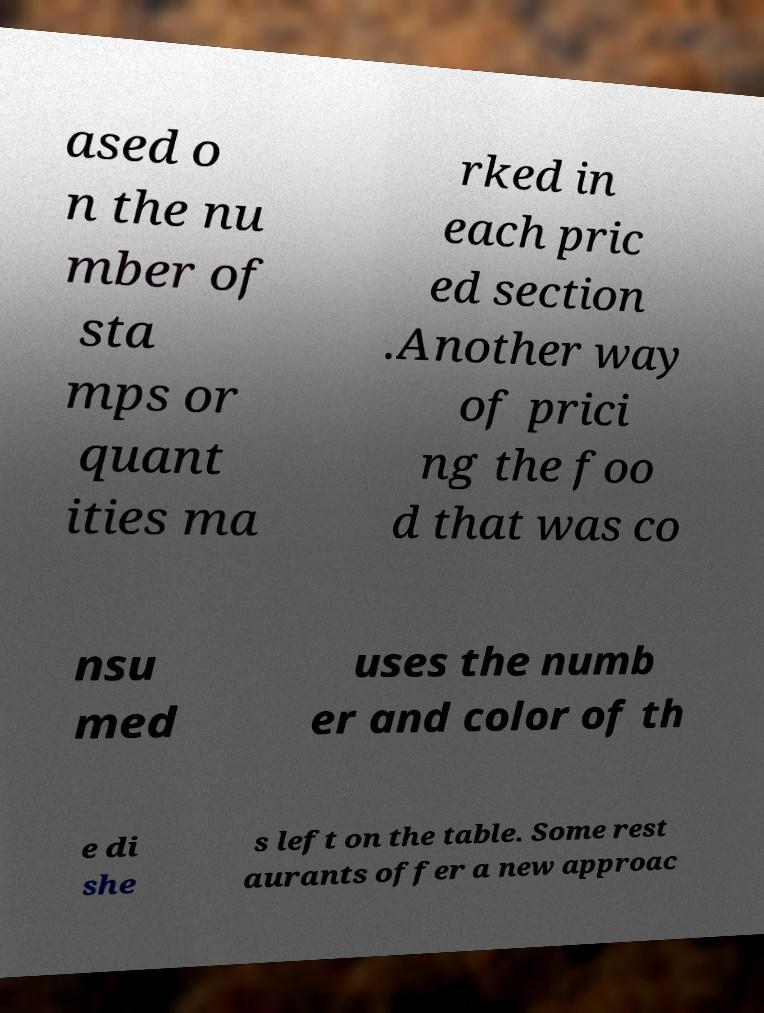I need the written content from this picture converted into text. Can you do that? ased o n the nu mber of sta mps or quant ities ma rked in each pric ed section .Another way of prici ng the foo d that was co nsu med uses the numb er and color of th e di she s left on the table. Some rest aurants offer a new approac 